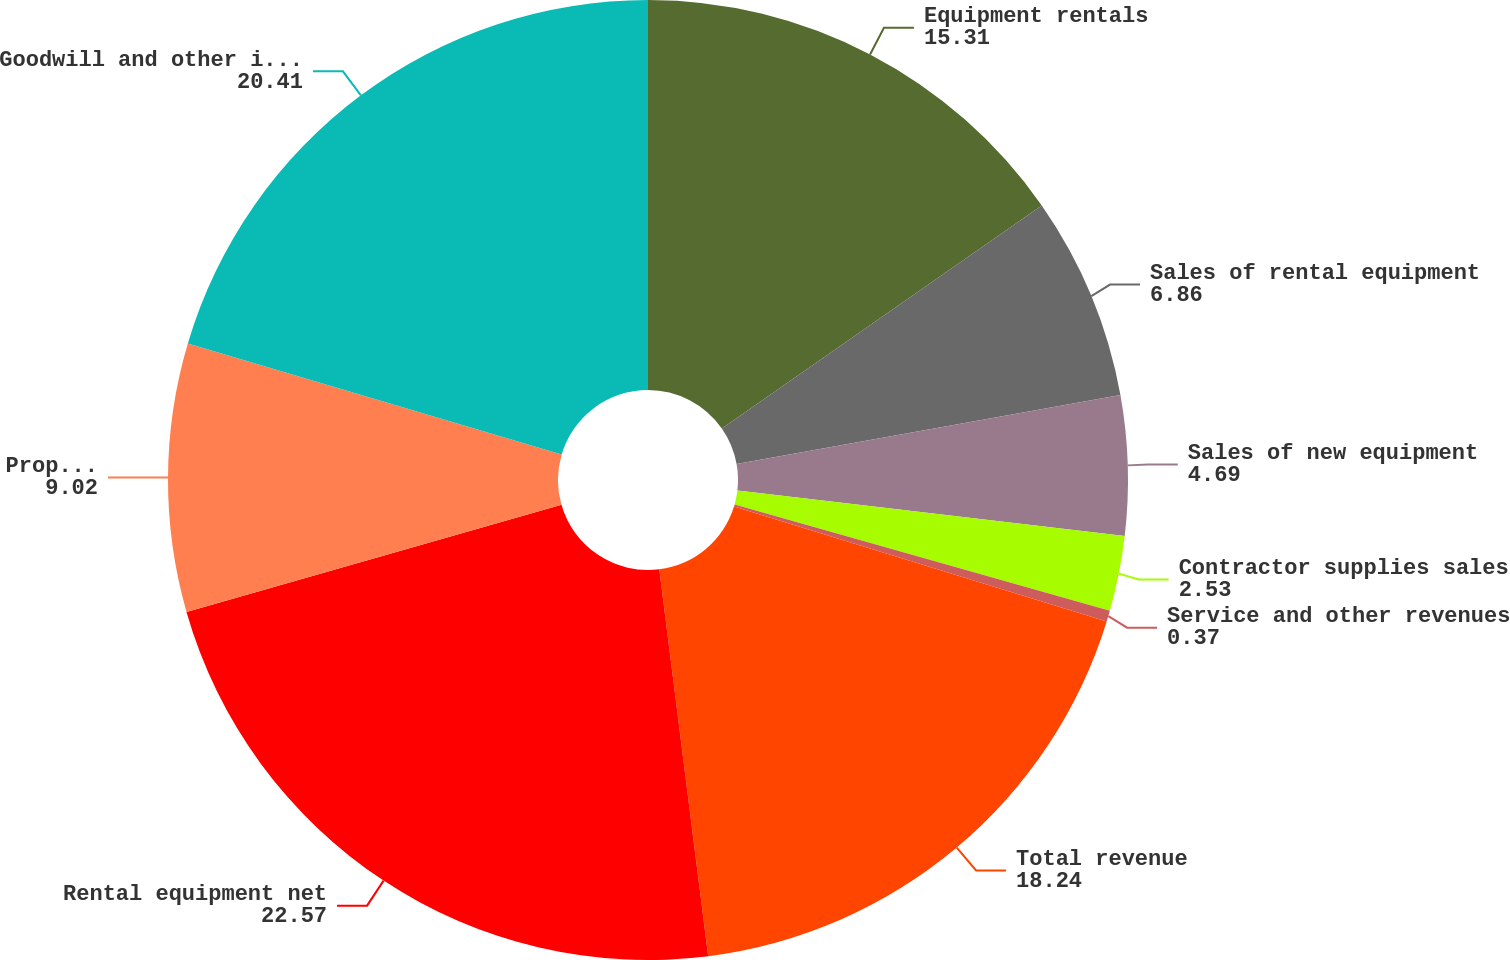Convert chart. <chart><loc_0><loc_0><loc_500><loc_500><pie_chart><fcel>Equipment rentals<fcel>Sales of rental equipment<fcel>Sales of new equipment<fcel>Contractor supplies sales<fcel>Service and other revenues<fcel>Total revenue<fcel>Rental equipment net<fcel>Property and equipment net<fcel>Goodwill and other intangibles<nl><fcel>15.31%<fcel>6.86%<fcel>4.69%<fcel>2.53%<fcel>0.37%<fcel>18.24%<fcel>22.57%<fcel>9.02%<fcel>20.41%<nl></chart> 